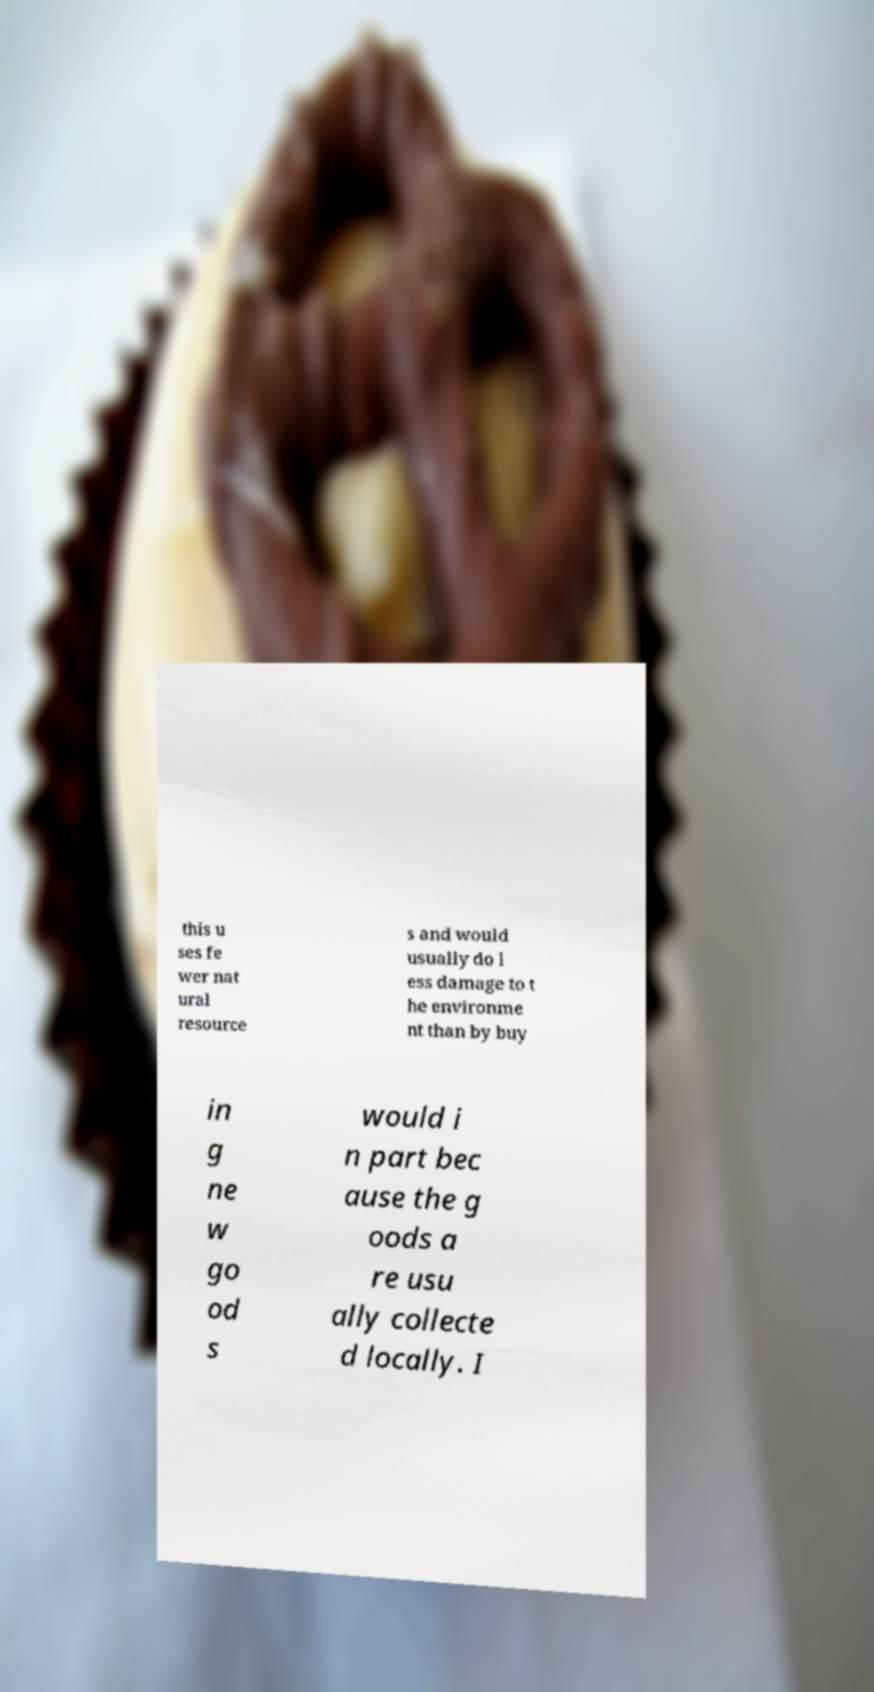I need the written content from this picture converted into text. Can you do that? this u ses fe wer nat ural resource s and would usually do l ess damage to t he environme nt than by buy in g ne w go od s would i n part bec ause the g oods a re usu ally collecte d locally. I 